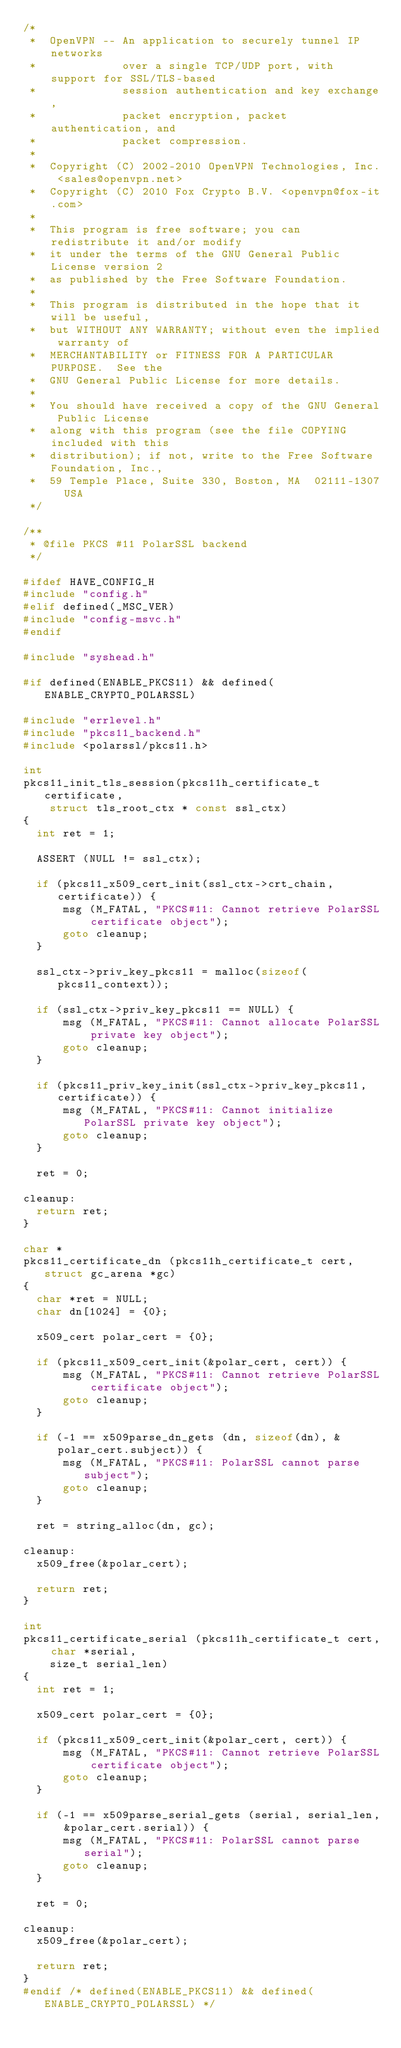Convert code to text. <code><loc_0><loc_0><loc_500><loc_500><_C_>/*
 *  OpenVPN -- An application to securely tunnel IP networks
 *             over a single TCP/UDP port, with support for SSL/TLS-based
 *             session authentication and key exchange,
 *             packet encryption, packet authentication, and
 *             packet compression.
 *
 *  Copyright (C) 2002-2010 OpenVPN Technologies, Inc. <sales@openvpn.net>
 *  Copyright (C) 2010 Fox Crypto B.V. <openvpn@fox-it.com>
 *
 *  This program is free software; you can redistribute it and/or modify
 *  it under the terms of the GNU General Public License version 2
 *  as published by the Free Software Foundation.
 *
 *  This program is distributed in the hope that it will be useful,
 *  but WITHOUT ANY WARRANTY; without even the implied warranty of
 *  MERCHANTABILITY or FITNESS FOR A PARTICULAR PURPOSE.  See the
 *  GNU General Public License for more details.
 *
 *  You should have received a copy of the GNU General Public License
 *  along with this program (see the file COPYING included with this
 *  distribution); if not, write to the Free Software Foundation, Inc.,
 *  59 Temple Place, Suite 330, Boston, MA  02111-1307  USA
 */

/**
 * @file PKCS #11 PolarSSL backend
 */

#ifdef HAVE_CONFIG_H
#include "config.h"
#elif defined(_MSC_VER)
#include "config-msvc.h"
#endif

#include "syshead.h"

#if defined(ENABLE_PKCS11) && defined(ENABLE_CRYPTO_POLARSSL)

#include "errlevel.h"
#include "pkcs11_backend.h"
#include <polarssl/pkcs11.h>

int
pkcs11_init_tls_session(pkcs11h_certificate_t certificate,
    struct tls_root_ctx * const ssl_ctx)
{
  int ret = 1;

  ASSERT (NULL != ssl_ctx);

  if (pkcs11_x509_cert_init(ssl_ctx->crt_chain, certificate)) {
      msg (M_FATAL, "PKCS#11: Cannot retrieve PolarSSL certificate object");
      goto cleanup;
  }

  ssl_ctx->priv_key_pkcs11 = malloc(sizeof(pkcs11_context));

  if (ssl_ctx->priv_key_pkcs11 == NULL) {
      msg (M_FATAL, "PKCS#11: Cannot allocate PolarSSL private key object");
      goto cleanup;
  }

  if (pkcs11_priv_key_init(ssl_ctx->priv_key_pkcs11, certificate)) {
      msg (M_FATAL, "PKCS#11: Cannot initialize PolarSSL private key object");
      goto cleanup;
  }

  ret = 0;

cleanup:
  return ret;
}

char *
pkcs11_certificate_dn (pkcs11h_certificate_t cert, struct gc_arena *gc)
{
  char *ret = NULL;
  char dn[1024] = {0};

  x509_cert polar_cert = {0};

  if (pkcs11_x509_cert_init(&polar_cert, cert)) {
      msg (M_FATAL, "PKCS#11: Cannot retrieve PolarSSL certificate object");
      goto cleanup;
  }

  if (-1 == x509parse_dn_gets (dn, sizeof(dn), &polar_cert.subject)) {
      msg (M_FATAL, "PKCS#11: PolarSSL cannot parse subject");
      goto cleanup;
  }

  ret = string_alloc(dn, gc);

cleanup:
  x509_free(&polar_cert);

  return ret;
}

int
pkcs11_certificate_serial (pkcs11h_certificate_t cert, char *serial,
    size_t serial_len)
{
  int ret = 1;

  x509_cert polar_cert = {0};

  if (pkcs11_x509_cert_init(&polar_cert, cert)) {
      msg (M_FATAL, "PKCS#11: Cannot retrieve PolarSSL certificate object");
      goto cleanup;
  }

  if (-1 == x509parse_serial_gets (serial, serial_len, &polar_cert.serial)) {
      msg (M_FATAL, "PKCS#11: PolarSSL cannot parse serial");
      goto cleanup;
  }

  ret = 0;

cleanup:
  x509_free(&polar_cert);

  return ret;
}
#endif /* defined(ENABLE_PKCS11) && defined(ENABLE_CRYPTO_POLARSSL) */
</code> 